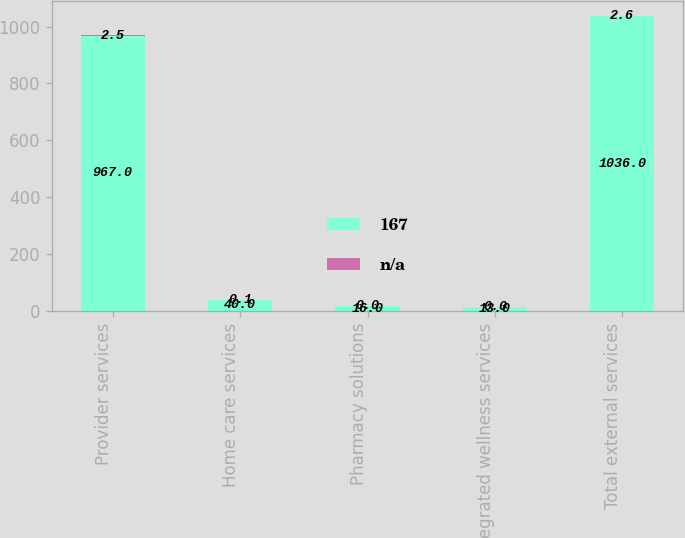Convert chart to OTSL. <chart><loc_0><loc_0><loc_500><loc_500><stacked_bar_chart><ecel><fcel>Provider services<fcel>Home care services<fcel>Pharmacy solutions<fcel>Integrated wellness services<fcel>Total external services<nl><fcel>167<fcel>967<fcel>40<fcel>16<fcel>13<fcel>1036<nl><fcel>nan<fcel>2.5<fcel>0.1<fcel>0<fcel>0<fcel>2.6<nl></chart> 